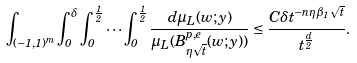<formula> <loc_0><loc_0><loc_500><loc_500>\int _ { ( - 1 , 1 ) ^ { m } } \int _ { 0 } ^ { \delta } \int _ { 0 } ^ { \frac { 1 } { 2 } } \cdots \int _ { 0 } ^ { \frac { 1 } { 2 } } \frac { d \mu _ { L } ( w ; y ) } { \mu _ { L } ( B ^ { p , e } _ { \eta \sqrt { t } } ( w ; y ) ) } \leq \frac { C \delta t ^ { - n \eta \beta _ { 1 } \sqrt { t } } } { t ^ { \frac { d } { 2 } } } .</formula> 